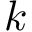Convert formula to latex. <formula><loc_0><loc_0><loc_500><loc_500>k</formula> 